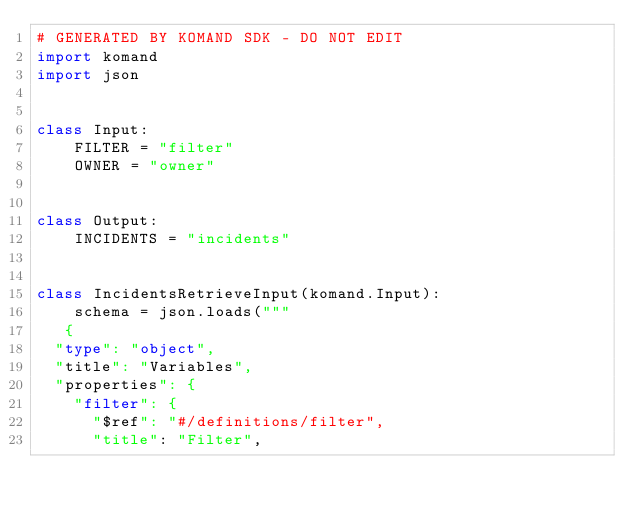Convert code to text. <code><loc_0><loc_0><loc_500><loc_500><_Python_># GENERATED BY KOMAND SDK - DO NOT EDIT
import komand
import json


class Input:
    FILTER = "filter"
    OWNER = "owner"
    

class Output:
    INCIDENTS = "incidents"
    

class IncidentsRetrieveInput(komand.Input):
    schema = json.loads("""
   {
  "type": "object",
  "title": "Variables",
  "properties": {
    "filter": {
      "$ref": "#/definitions/filter",
      "title": "Filter",</code> 